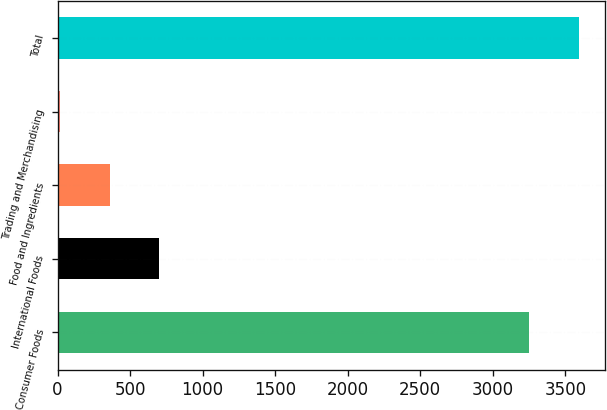Convert chart to OTSL. <chart><loc_0><loc_0><loc_500><loc_500><bar_chart><fcel>Consumer Foods<fcel>International Foods<fcel>Food and Ingredients<fcel>Trading and Merchandising<fcel>Total<nl><fcel>3252.1<fcel>702.1<fcel>359<fcel>15.9<fcel>3595.2<nl></chart> 